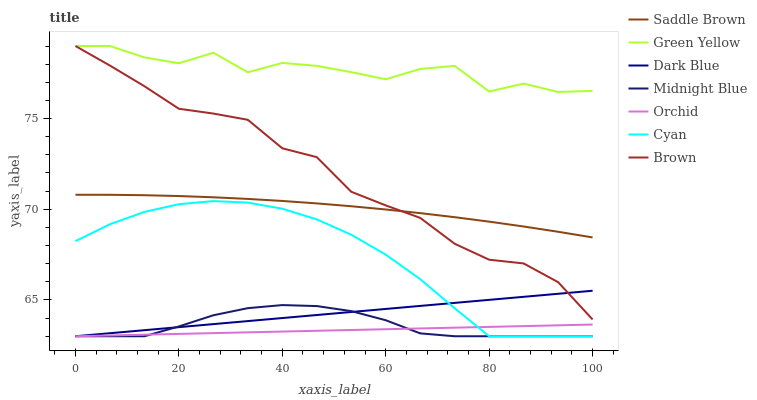Does Orchid have the minimum area under the curve?
Answer yes or no. Yes. Does Green Yellow have the maximum area under the curve?
Answer yes or no. Yes. Does Midnight Blue have the minimum area under the curve?
Answer yes or no. No. Does Midnight Blue have the maximum area under the curve?
Answer yes or no. No. Is Dark Blue the smoothest?
Answer yes or no. Yes. Is Green Yellow the roughest?
Answer yes or no. Yes. Is Midnight Blue the smoothest?
Answer yes or no. No. Is Midnight Blue the roughest?
Answer yes or no. No. Does Midnight Blue have the lowest value?
Answer yes or no. Yes. Does Green Yellow have the lowest value?
Answer yes or no. No. Does Green Yellow have the highest value?
Answer yes or no. Yes. Does Midnight Blue have the highest value?
Answer yes or no. No. Is Dark Blue less than Green Yellow?
Answer yes or no. Yes. Is Green Yellow greater than Midnight Blue?
Answer yes or no. Yes. Does Orchid intersect Midnight Blue?
Answer yes or no. Yes. Is Orchid less than Midnight Blue?
Answer yes or no. No. Is Orchid greater than Midnight Blue?
Answer yes or no. No. Does Dark Blue intersect Green Yellow?
Answer yes or no. No. 